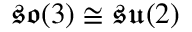<formula> <loc_0><loc_0><loc_500><loc_500>{ \mathfrak { s o } } ( 3 ) \cong { \mathfrak { s u } } ( 2 )</formula> 